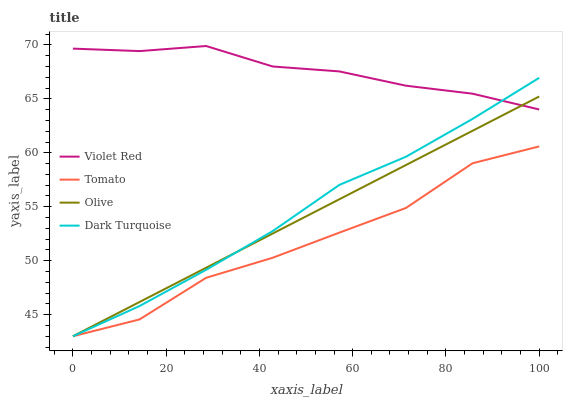Does Olive have the minimum area under the curve?
Answer yes or no. No. Does Olive have the maximum area under the curve?
Answer yes or no. No. Is Violet Red the smoothest?
Answer yes or no. No. Is Violet Red the roughest?
Answer yes or no. No. Does Violet Red have the lowest value?
Answer yes or no. No. Does Olive have the highest value?
Answer yes or no. No. Is Tomato less than Violet Red?
Answer yes or no. Yes. Is Violet Red greater than Tomato?
Answer yes or no. Yes. Does Tomato intersect Violet Red?
Answer yes or no. No. 